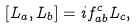Convert formula to latex. <formula><loc_0><loc_0><loc_500><loc_500>[ L _ { a } , L _ { b } ] = i f _ { a b } ^ { c } L _ { c } ,</formula> 